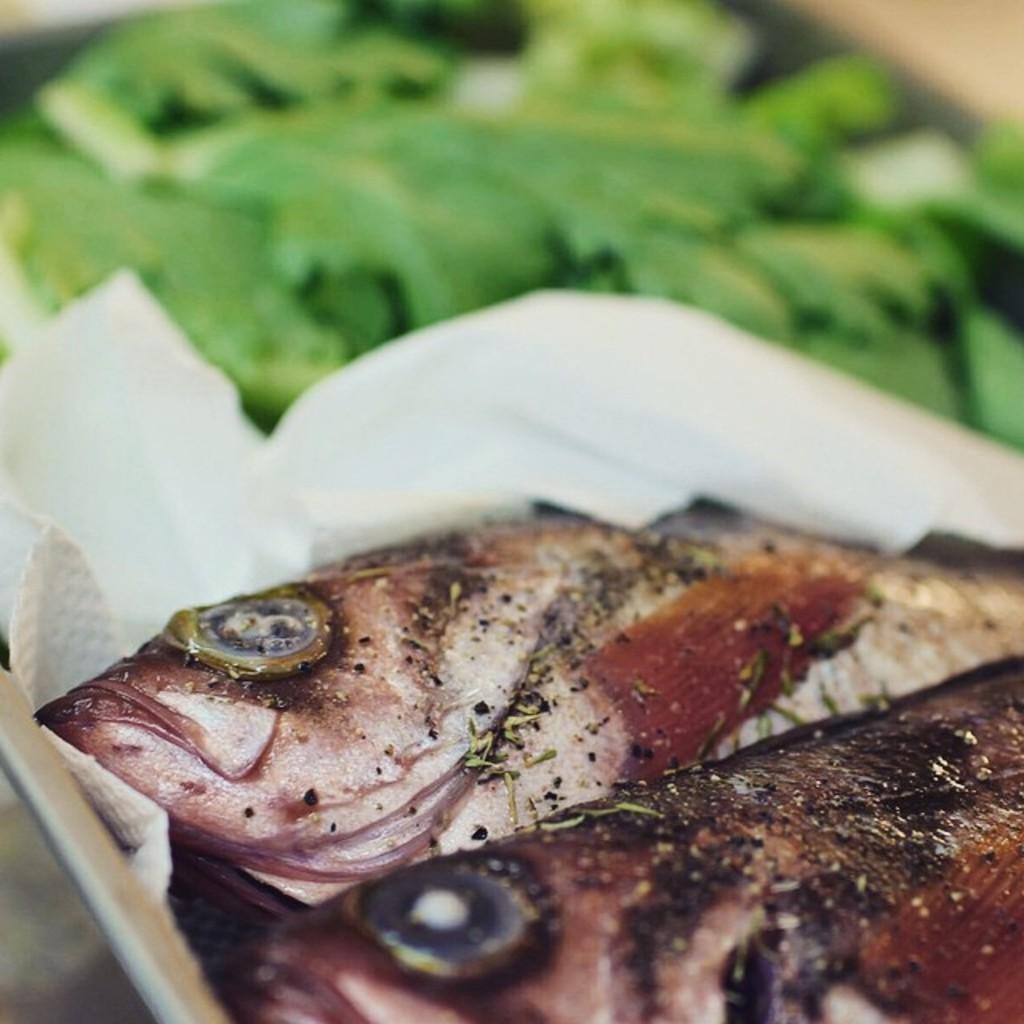Please provide a concise description of this image. In this image there are two fish pieces in the tissue paper. In the background there are green leaves. 